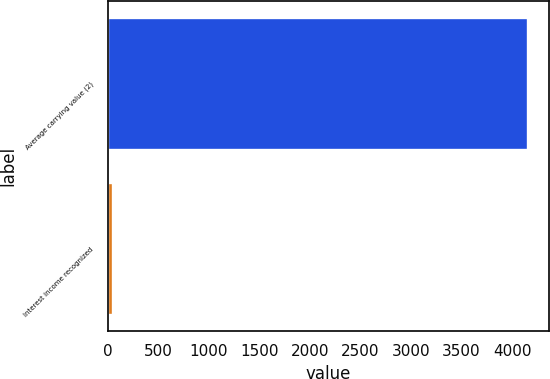Convert chart to OTSL. <chart><loc_0><loc_0><loc_500><loc_500><bar_chart><fcel>Average carrying value (2)<fcel>Interest income recognized<nl><fcel>4157<fcel>49<nl></chart> 